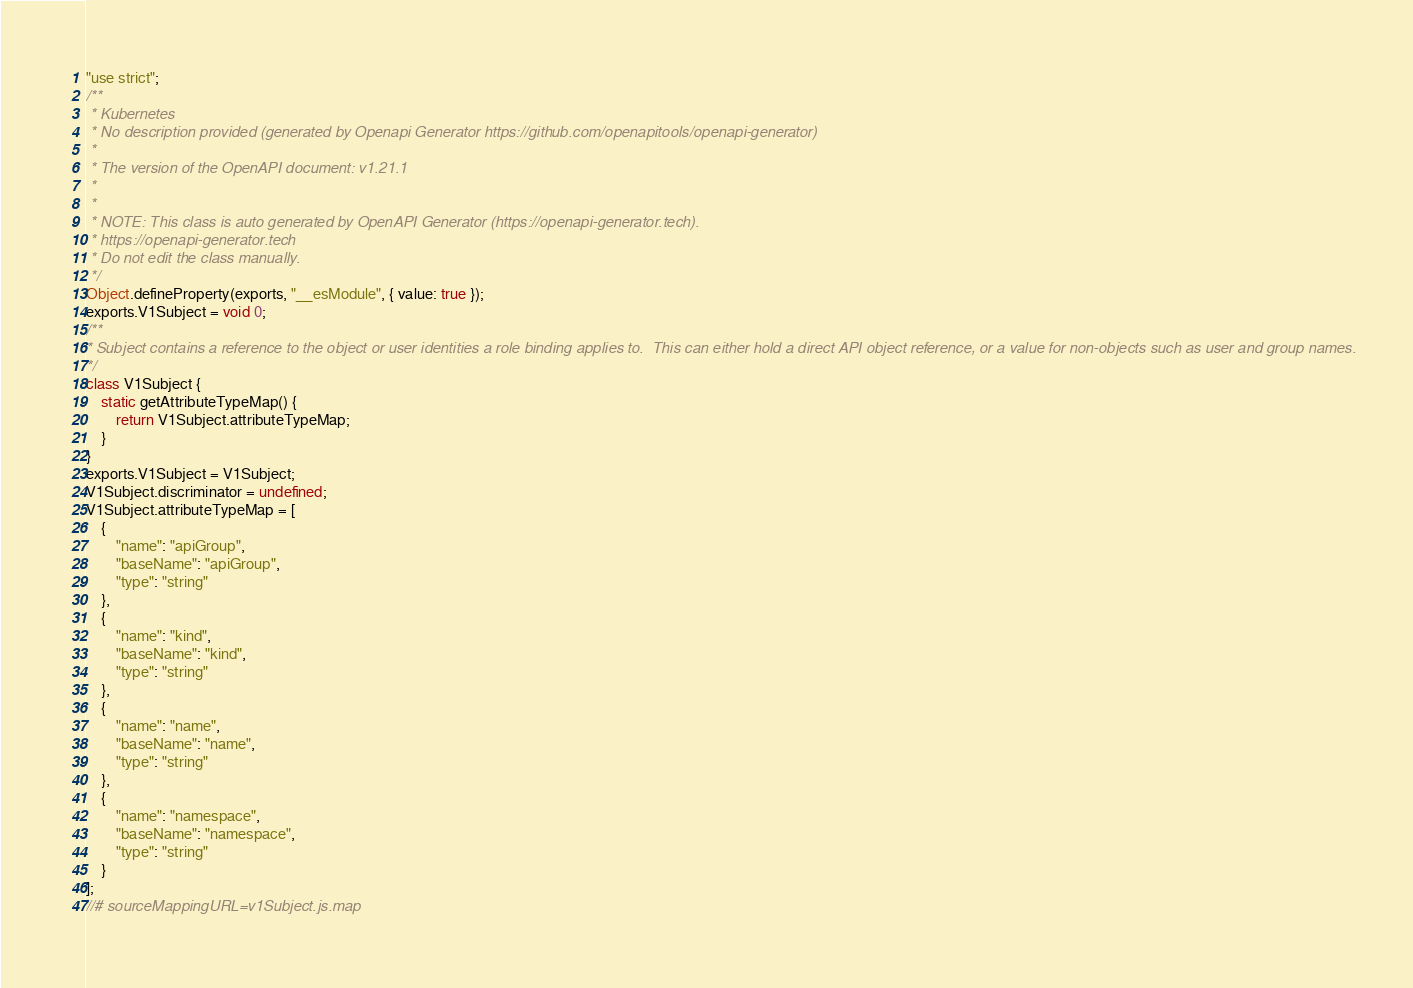<code> <loc_0><loc_0><loc_500><loc_500><_JavaScript_>"use strict";
/**
 * Kubernetes
 * No description provided (generated by Openapi Generator https://github.com/openapitools/openapi-generator)
 *
 * The version of the OpenAPI document: v1.21.1
 *
 *
 * NOTE: This class is auto generated by OpenAPI Generator (https://openapi-generator.tech).
 * https://openapi-generator.tech
 * Do not edit the class manually.
 */
Object.defineProperty(exports, "__esModule", { value: true });
exports.V1Subject = void 0;
/**
* Subject contains a reference to the object or user identities a role binding applies to.  This can either hold a direct API object reference, or a value for non-objects such as user and group names.
*/
class V1Subject {
    static getAttributeTypeMap() {
        return V1Subject.attributeTypeMap;
    }
}
exports.V1Subject = V1Subject;
V1Subject.discriminator = undefined;
V1Subject.attributeTypeMap = [
    {
        "name": "apiGroup",
        "baseName": "apiGroup",
        "type": "string"
    },
    {
        "name": "kind",
        "baseName": "kind",
        "type": "string"
    },
    {
        "name": "name",
        "baseName": "name",
        "type": "string"
    },
    {
        "name": "namespace",
        "baseName": "namespace",
        "type": "string"
    }
];
//# sourceMappingURL=v1Subject.js.map</code> 